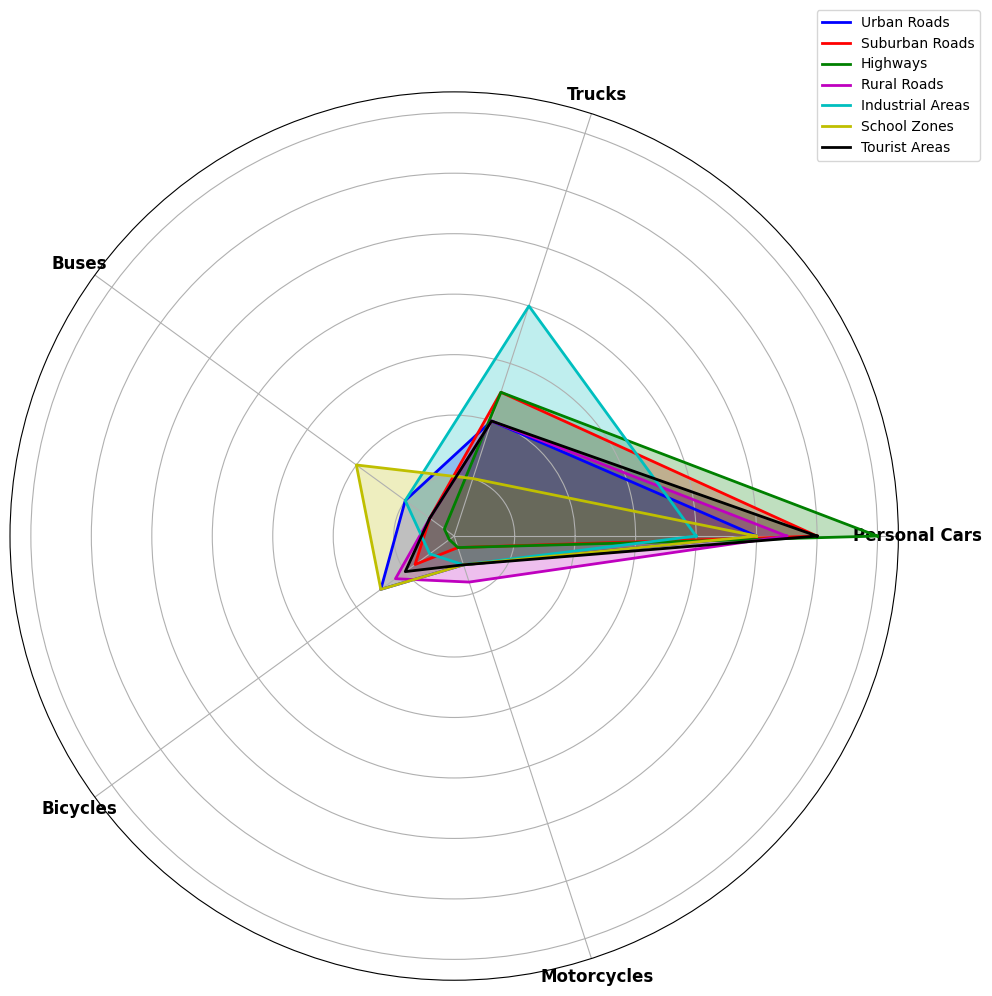Which vehicle type contributes the most to traffic volume on highways? The radar chart shows that the segment for Personal Cars is the largest on highways.
Answer: Personal Cars Which road type sees the highest contribution from Trucks? The radar chart indicates that Trucks contribute the most in Industrial Areas.
Answer: Industrial Areas Compare the contribution of Motorcycles in Urban Roads and Rural Roads. Which one is higher? By observing the chart, the segment for Motorcycles is larger in Rural Roads than in Urban Roads.
Answer: Rural Roads What is the difference in the contribution of Personal Cars between Highways and Suburban Roads? Personal Cars contribute 70% on Highways and 60% on Suburban Roads; the difference is 70% - 60%.
Answer: 10% Which vehicle type shows the lowest contribution in School Zones? The radar chart shows that Motorcycles have the smallest segment in School Zones.
Answer: Motorcycles Sum up the contributions of Personal Cars across all road types. Adding up the contributions: 50 (Urban) + 60 (Suburban) + 70 (Highways) + 55 (Rural) + 40 (Industrial) + 50 (School Zones) + 60 (Tourist Areas) = 385.
Answer: 385% In which road type do Buses have the highest contribution to traffic volume? The radar chart shows that Buses contribute the highest in School Zones.
Answer: School Zones Compare the contribution of Bicycles in Urban Roads and Tourist Areas. Which one is higher? The chart shows that Bicycles contribute more to traffic volume in Urban Roads than in Tourist Areas.
Answer: Urban Roads Which road type exhibits an equal contribution from Personal Cars and Trucks? On Industrial Areas, both Personal Cars and Trucks have the same contribution, as shown in the radar chart.
Answer: Industrial Areas What is the average contribution of Buses in all road types? Summing the contributions: 10 (Urban) + 5 (Suburban) + 2 (Highways) + 5 (Rural) + 10 (Industrial) + 20 (School Zones) + 5 (Tourist Areas) = 57. Dividing by the number of road types (7): 57 / 7 ≈ 8.14.
Answer: ~8.14% 